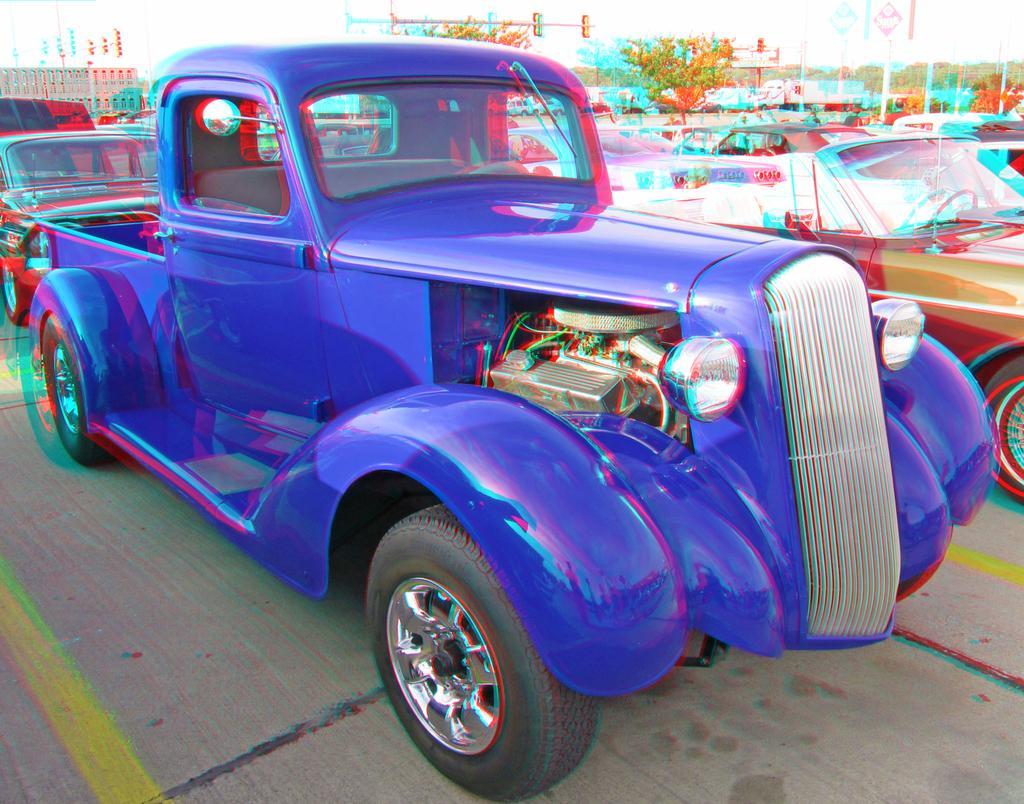Please provide a concise description of this image. In this picture we can see so many cars are parked in one place, back side, we can see some trees and buildings. 